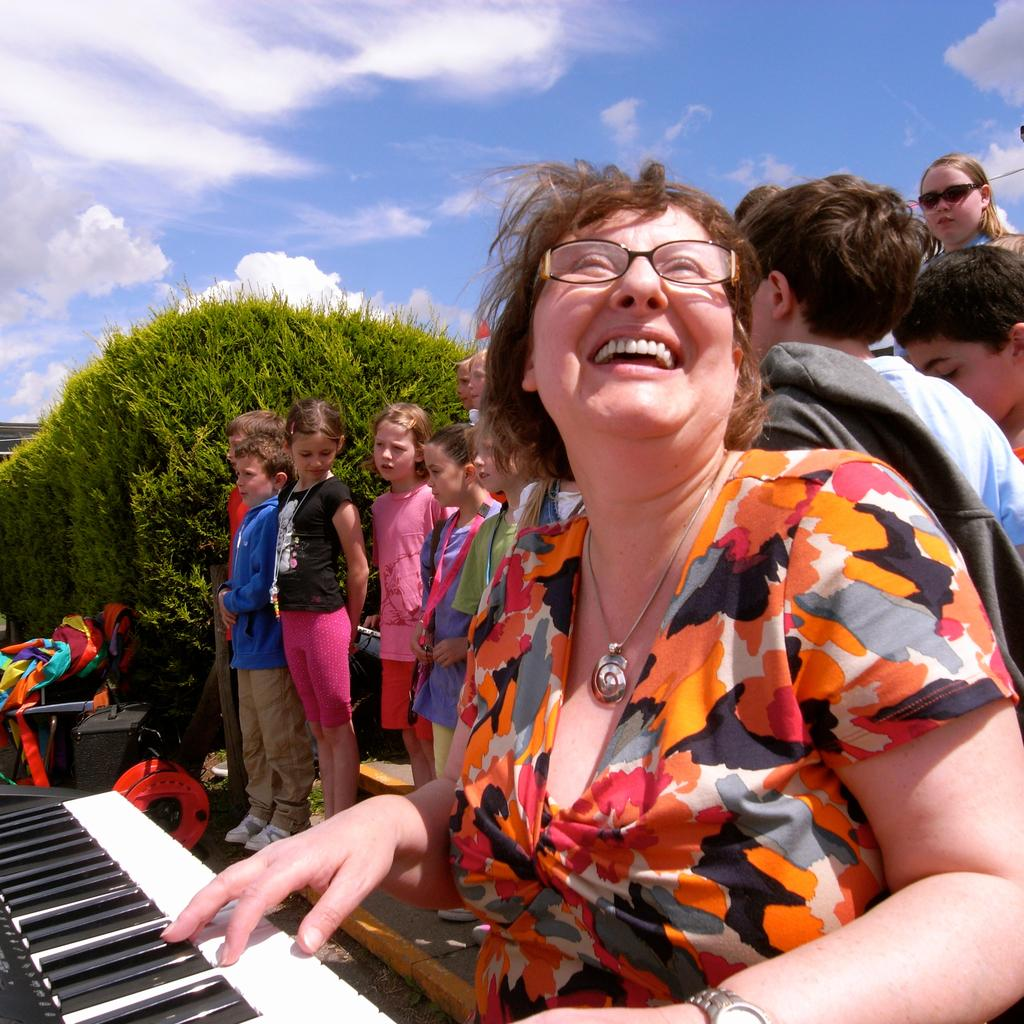What is the woman in the image doing? The woman is playing piano in the image. What can be seen in the background of the image? There are many kids in the background of the image. What is located on the left side of the image? There are trees on the left side of the image. What is visible in the sky in the image? The sky is visible in the image, and clouds are present. What type of pest can be seen crawling on the piano in the image? There is no pest visible on the piano in the image. What news headline is displayed on the piano in the image? There is no news headline present on the piano in the image. 